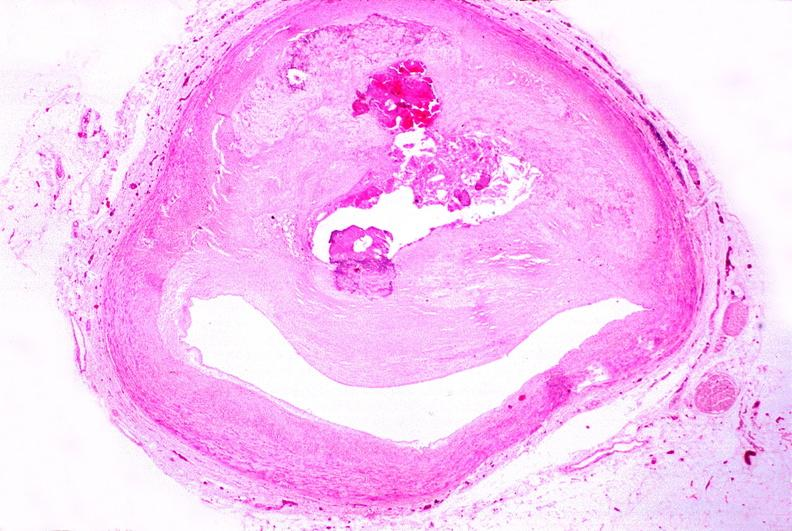s side present?
Answer the question using a single word or phrase. No 